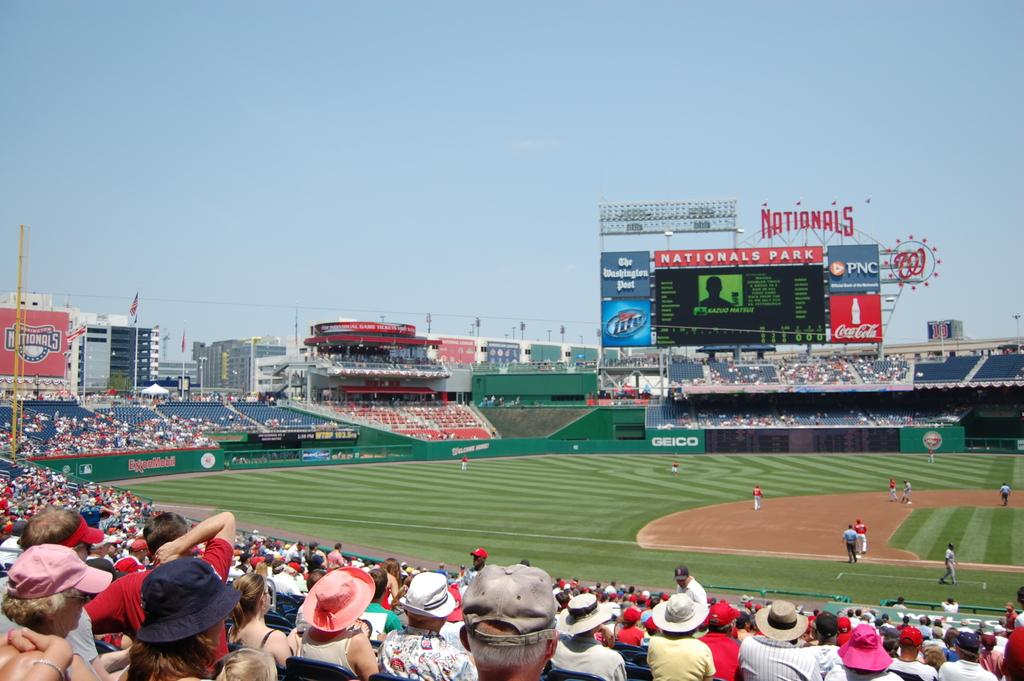<image>
Create a compact narrative representing the image presented. A partially full baseball stadium with a large billboard identifying it as Nationals Park. 